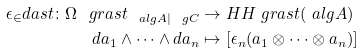Convert formula to latex. <formula><loc_0><loc_0><loc_500><loc_500>\epsilon _ { \in } d a s t \colon \Omega ^ { \ } g r a s t _ { \ a l g A | \ g C } & \rightarrow H H _ { \ } g r a s t ( \ a l g A ) \\ d a _ { 1 } \wedge \cdots \wedge d a _ { n } & \mapsto [ \epsilon _ { n } ( a _ { 1 } \otimes \cdots \otimes a _ { n } ) ]</formula> 